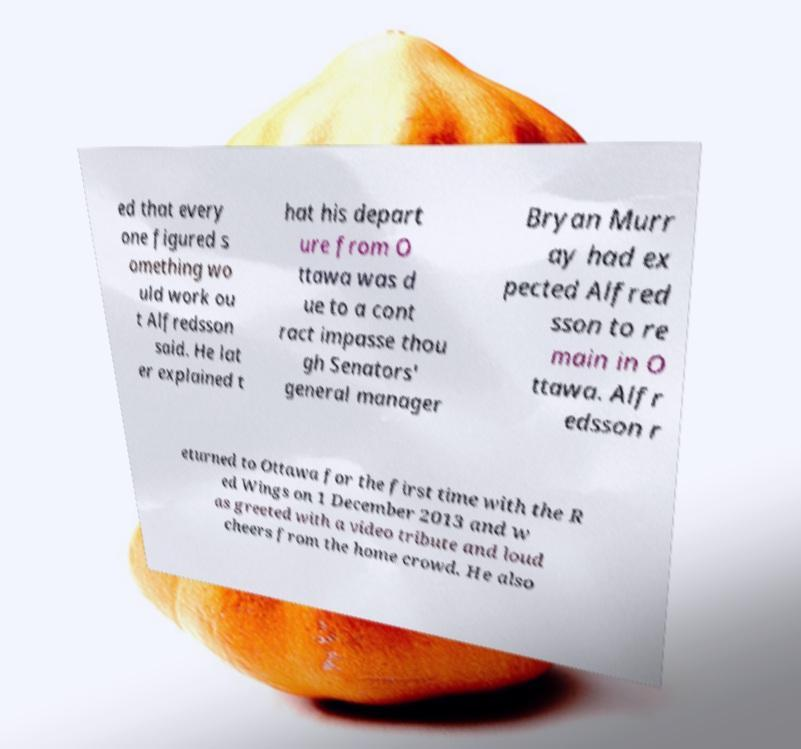Could you assist in decoding the text presented in this image and type it out clearly? ed that every one figured s omething wo uld work ou t Alfredsson said. He lat er explained t hat his depart ure from O ttawa was d ue to a cont ract impasse thou gh Senators' general manager Bryan Murr ay had ex pected Alfred sson to re main in O ttawa. Alfr edsson r eturned to Ottawa for the first time with the R ed Wings on 1 December 2013 and w as greeted with a video tribute and loud cheers from the home crowd. He also 